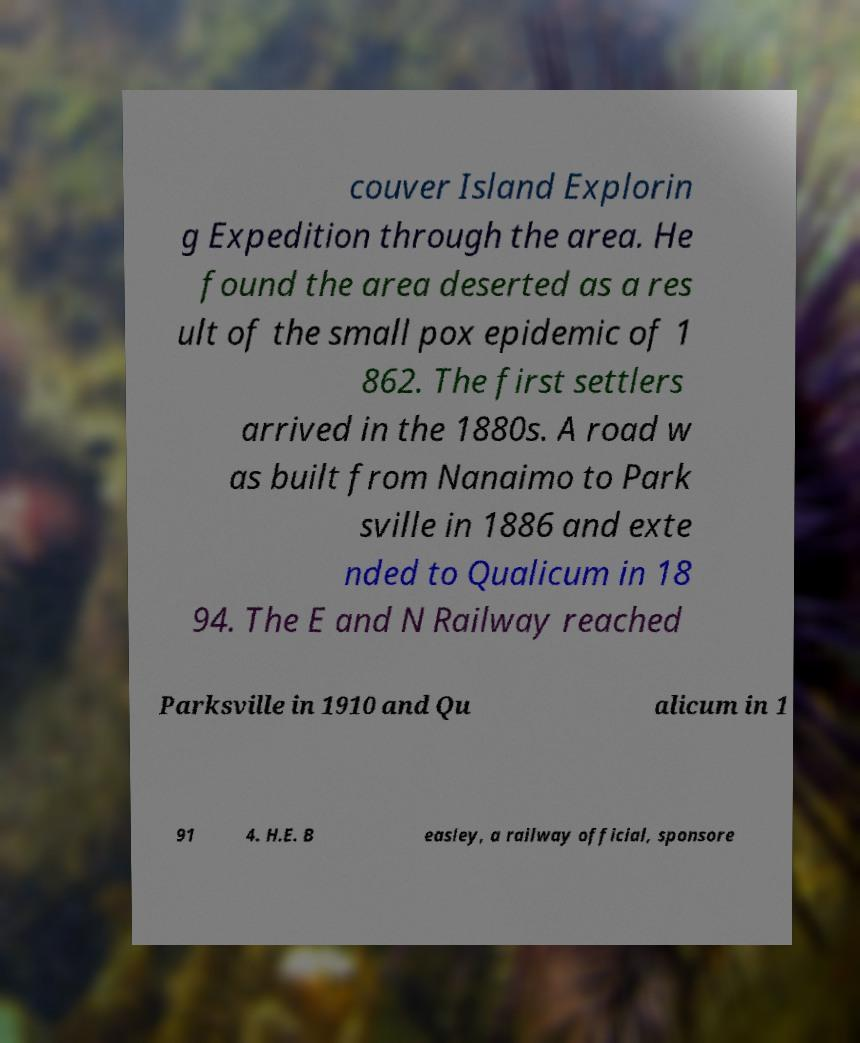Please read and relay the text visible in this image. What does it say? couver Island Explorin g Expedition through the area. He found the area deserted as a res ult of the small pox epidemic of 1 862. The first settlers arrived in the 1880s. A road w as built from Nanaimo to Park sville in 1886 and exte nded to Qualicum in 18 94. The E and N Railway reached Parksville in 1910 and Qu alicum in 1 91 4. H.E. B easley, a railway official, sponsore 